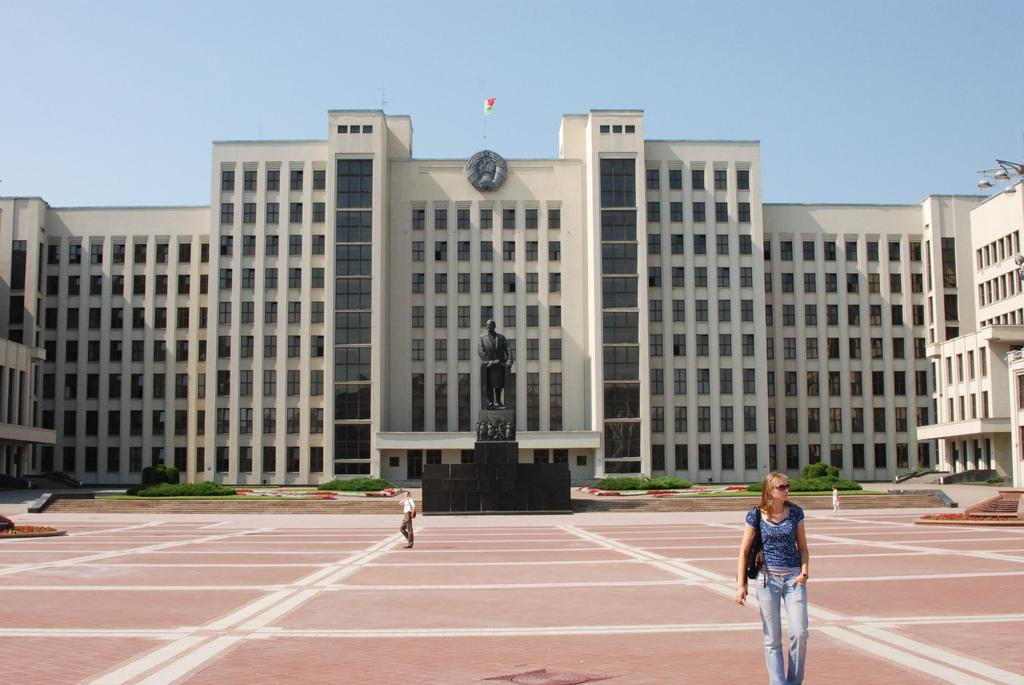What is the main subject of the image? The main subject of the image is a woman walking. Where is the woman located in the image? The woman is located in the bottom right hand corner of the image. What is the woman doing in the image? The woman is walking and looking at somewhere. What can be seen in the middle of the image? There is a statue in the middle of the image. What is visible in the background of the image? There is a building in the background of the image. What flavor of ice cream is the woman holding in the image? There is no ice cream present in the image; the woman is walking and looking at somewhere. 